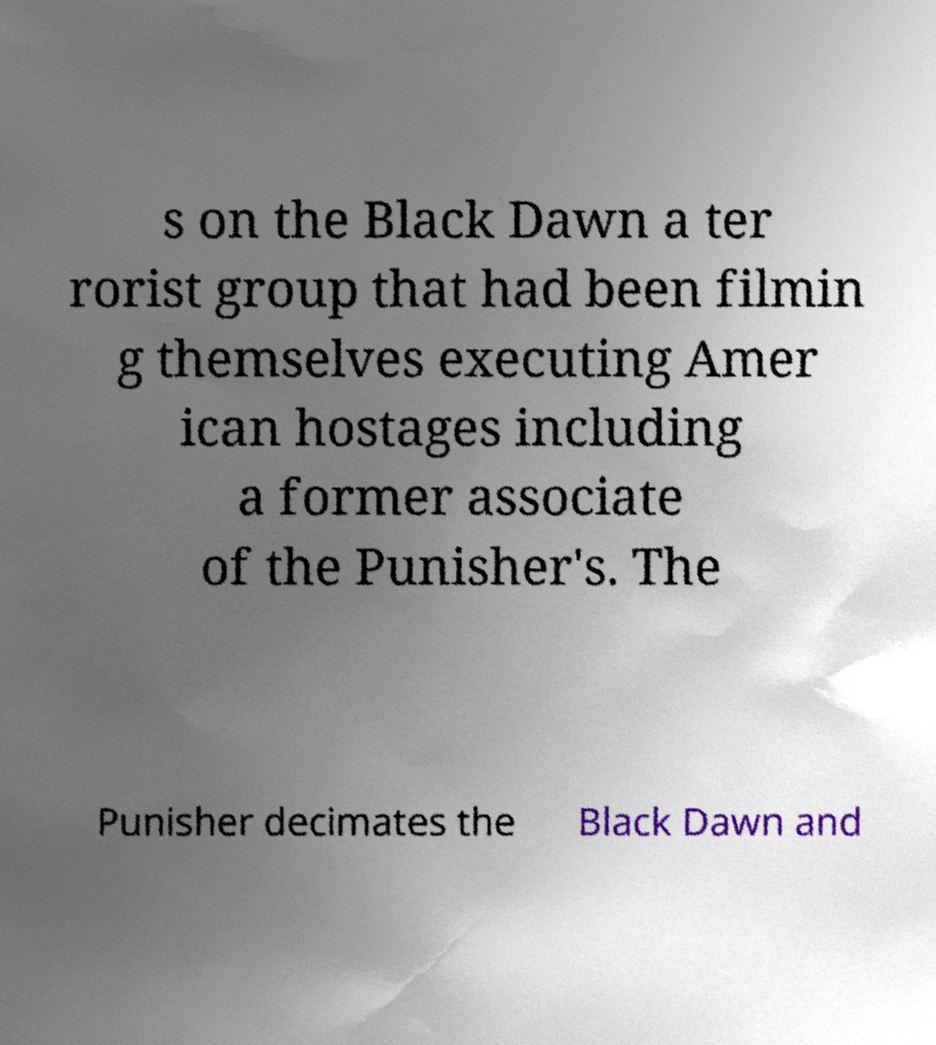Please read and relay the text visible in this image. What does it say? s on the Black Dawn a ter rorist group that had been filmin g themselves executing Amer ican hostages including a former associate of the Punisher's. The Punisher decimates the Black Dawn and 